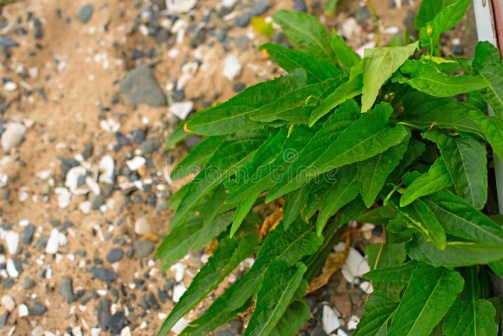Does the plant indicate anything about the environment? Indeed, the plant's presence and characteristics offer several clues about the surrounding environment. The robust and greenery of the plant suggest that it thrives in a more rugged, less cultivated area, possibly with poor soil quality. The small rocks and pebbles scattered around imply a landscape that is not overly lush, but rather hardy and resilient, possibly indicative of a mountainous or hilly region where such flora is common. The dirt path in the background adds to the suggestion that this could be a well-traveled trail in a natural setting, frequented by hikers or nature enthusiasts. 